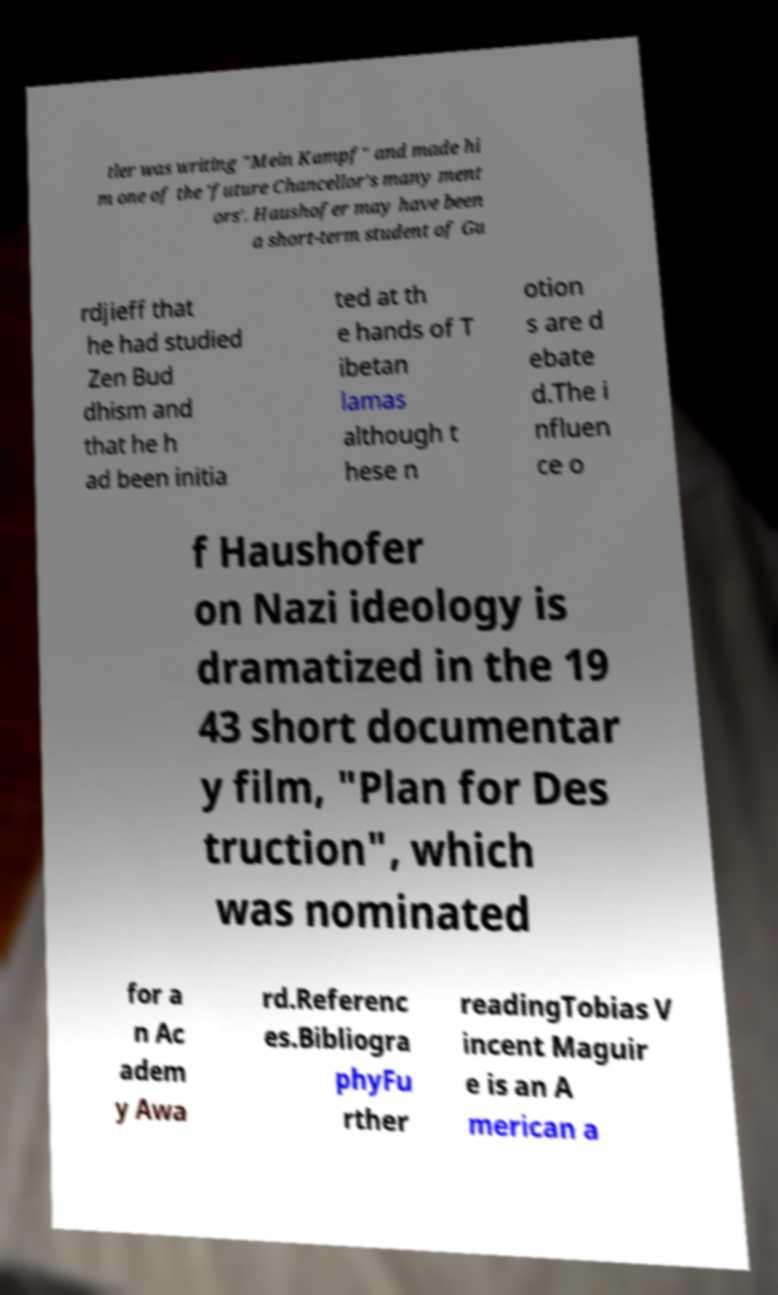Please identify and transcribe the text found in this image. tler was writing "Mein Kampf" and made hi m one of the 'future Chancellor's many ment ors'. Haushofer may have been a short-term student of Gu rdjieff that he had studied Zen Bud dhism and that he h ad been initia ted at th e hands of T ibetan lamas although t hese n otion s are d ebate d.The i nfluen ce o f Haushofer on Nazi ideology is dramatized in the 19 43 short documentar y film, "Plan for Des truction", which was nominated for a n Ac adem y Awa rd.Referenc es.Bibliogra phyFu rther readingTobias V incent Maguir e is an A merican a 